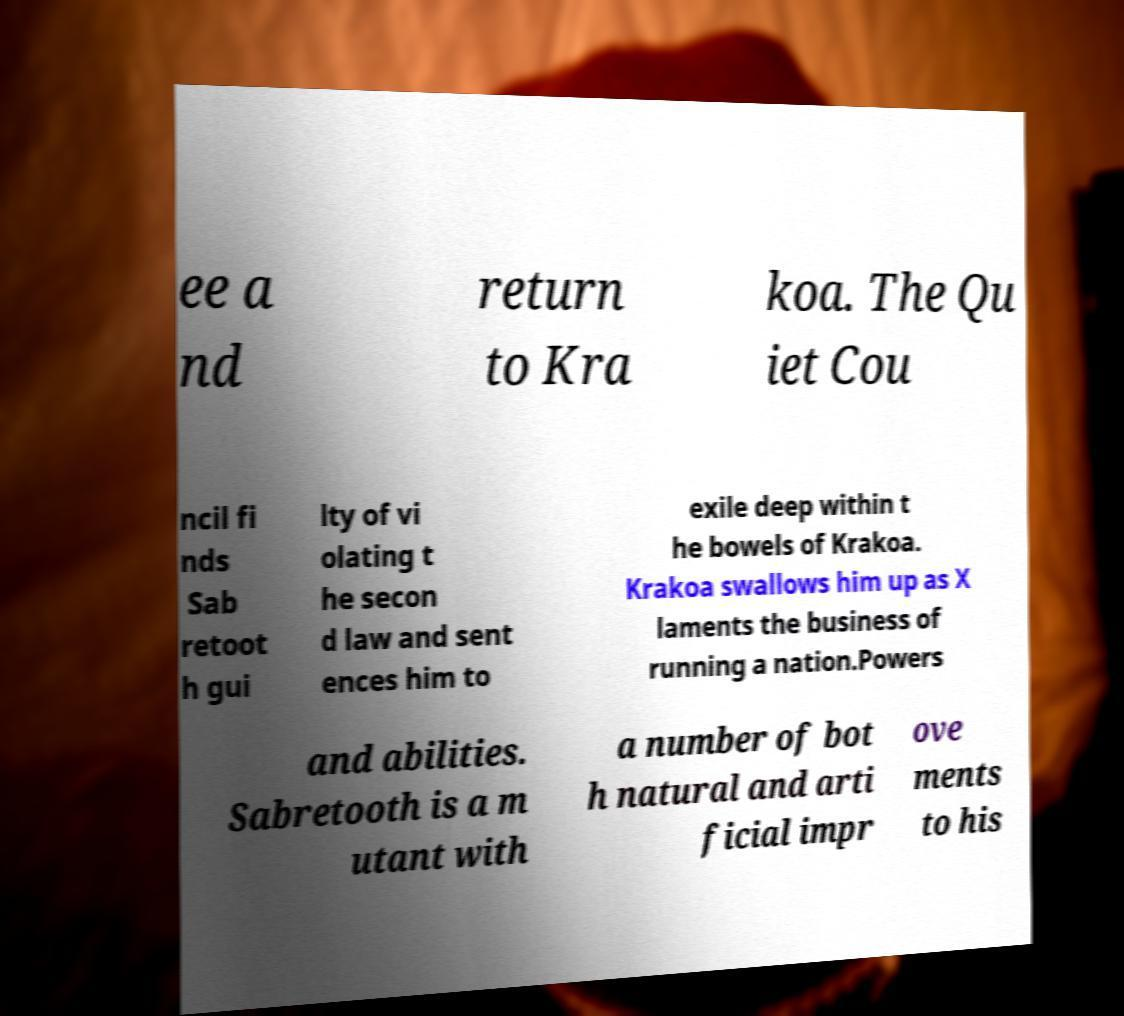Can you accurately transcribe the text from the provided image for me? ee a nd return to Kra koa. The Qu iet Cou ncil fi nds Sab retoot h gui lty of vi olating t he secon d law and sent ences him to exile deep within t he bowels of Krakoa. Krakoa swallows him up as X laments the business of running a nation.Powers and abilities. Sabretooth is a m utant with a number of bot h natural and arti ficial impr ove ments to his 